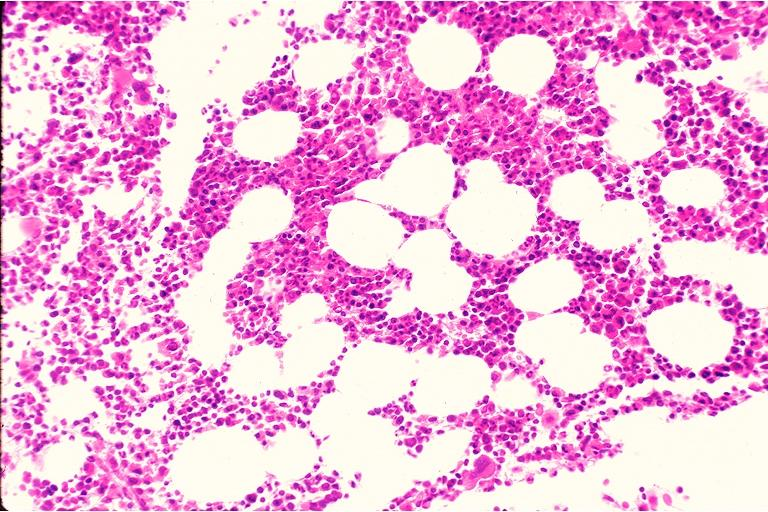where is this?
Answer the question using a single word or phrase. Oral 